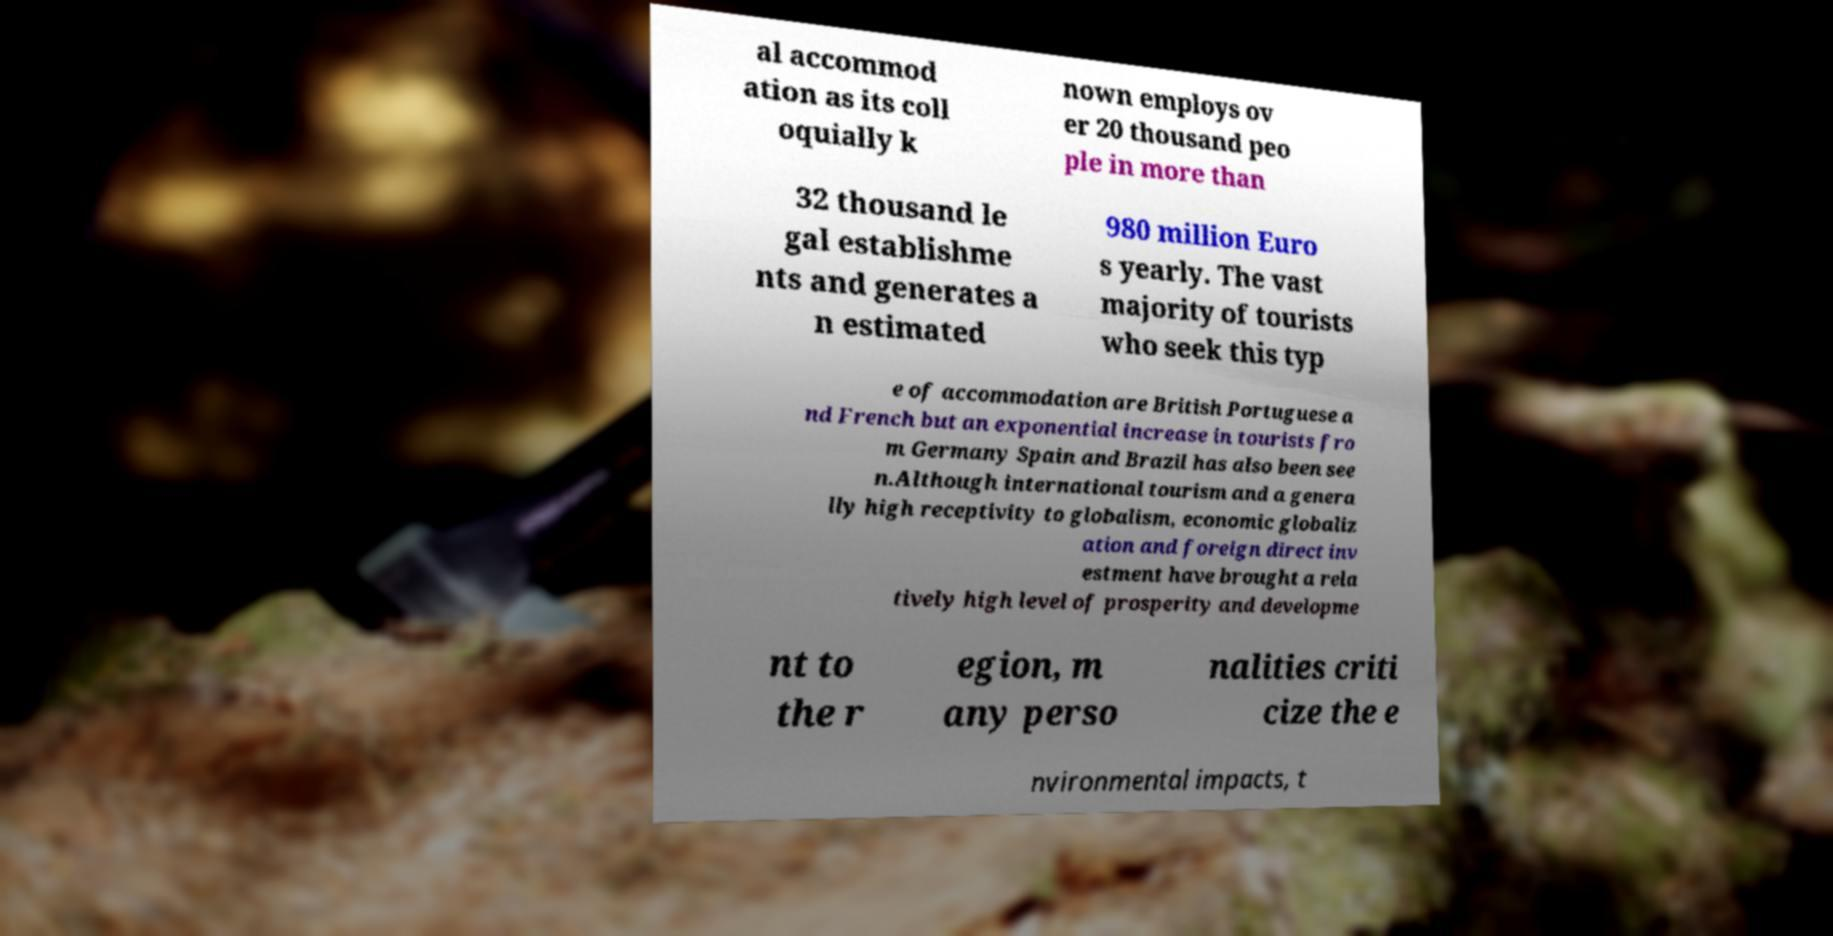What messages or text are displayed in this image? I need them in a readable, typed format. al accommod ation as its coll oquially k nown employs ov er 20 thousand peo ple in more than 32 thousand le gal establishme nts and generates a n estimated 980 million Euro s yearly. The vast majority of tourists who seek this typ e of accommodation are British Portuguese a nd French but an exponential increase in tourists fro m Germany Spain and Brazil has also been see n.Although international tourism and a genera lly high receptivity to globalism, economic globaliz ation and foreign direct inv estment have brought a rela tively high level of prosperity and developme nt to the r egion, m any perso nalities criti cize the e nvironmental impacts, t 